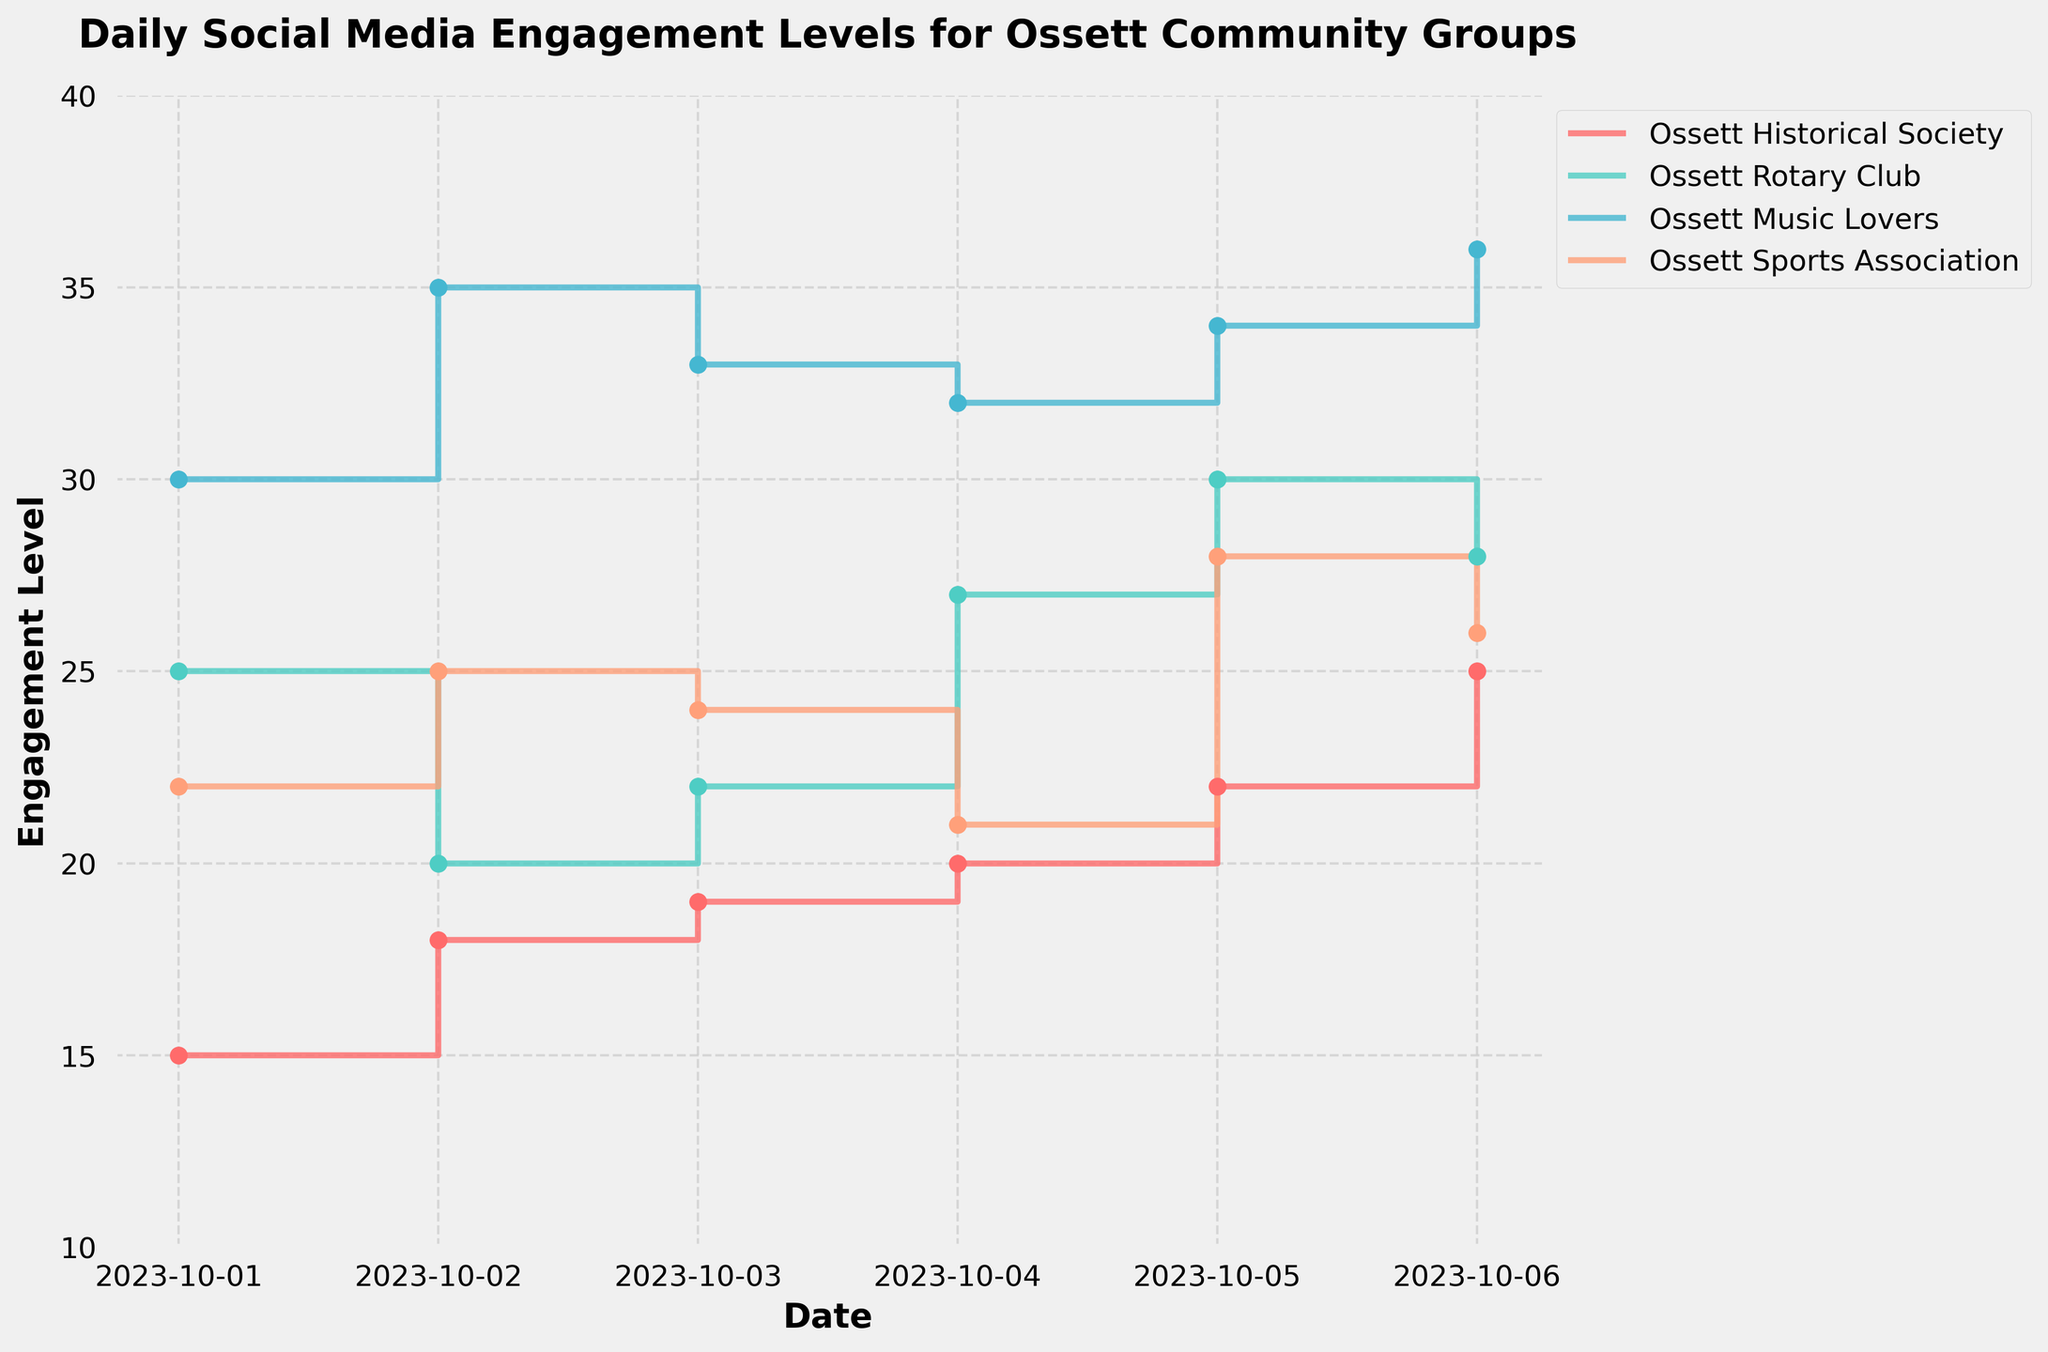What is the title of the plot? The title of the plot is found at the top and it should describe the visual information shown.
Answer: Daily Social Media Engagement Levels for Ossett Community Groups How many groups are shown in the plot? The plot's legend displays the names of the community groups represented in the plot.
Answer: 4 On which dates does the Ossett Music Lovers group have the highest engagement level? By observing the stair steps and the markers for Ossett Music Lovers, we can see the highest points.
Answer: October 6 What colors represent the Ossett Historical Society and Ossett Rotary Club? The legend matches each group with a specific color.
Answer: The Ossett Historical Society is red, and the Ossett Rotary Club is teal Which group has the lowest engagement level on October 1? By looking at the points corresponding to October 1 for all groups, identify the one with the lowest value.
Answer: Ossett Historical Society What is the range of engagement levels for the Ossett Rotary Club from October 1 to October 6? Check the highest and lowest engagement points for the Ossett Rotary Club over the dates.
Answer: 20 to 30 By how much did the Ossett Sports Association's engagement level change between October 2 and October 3? Subtract the engagement level on October 2 from the level on October 3 for the Ossett Sports Association.
Answer: -1 Which group had the most significant increase in engagement levels between any two consecutive dates? Look for the steepest upward steps for any group's stair plot.
Answer: Ossett Rotary Club (from October 4 to October 5) What is the average engagement level for the Ossett Historical Society from October 1 to October 6? Sum the engagement levels of Ossett Historical Society over these dates and divide by the number of data points (6).
Answer: 19.833 (rounded to 3 decimal places) Which group's engagement level remained within the narrowest range? Compare the range (maximum - minimum) of engagement levels for each group over the given dates.
Answer: Ossett Sports Association 